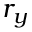Convert formula to latex. <formula><loc_0><loc_0><loc_500><loc_500>r _ { y }</formula> 